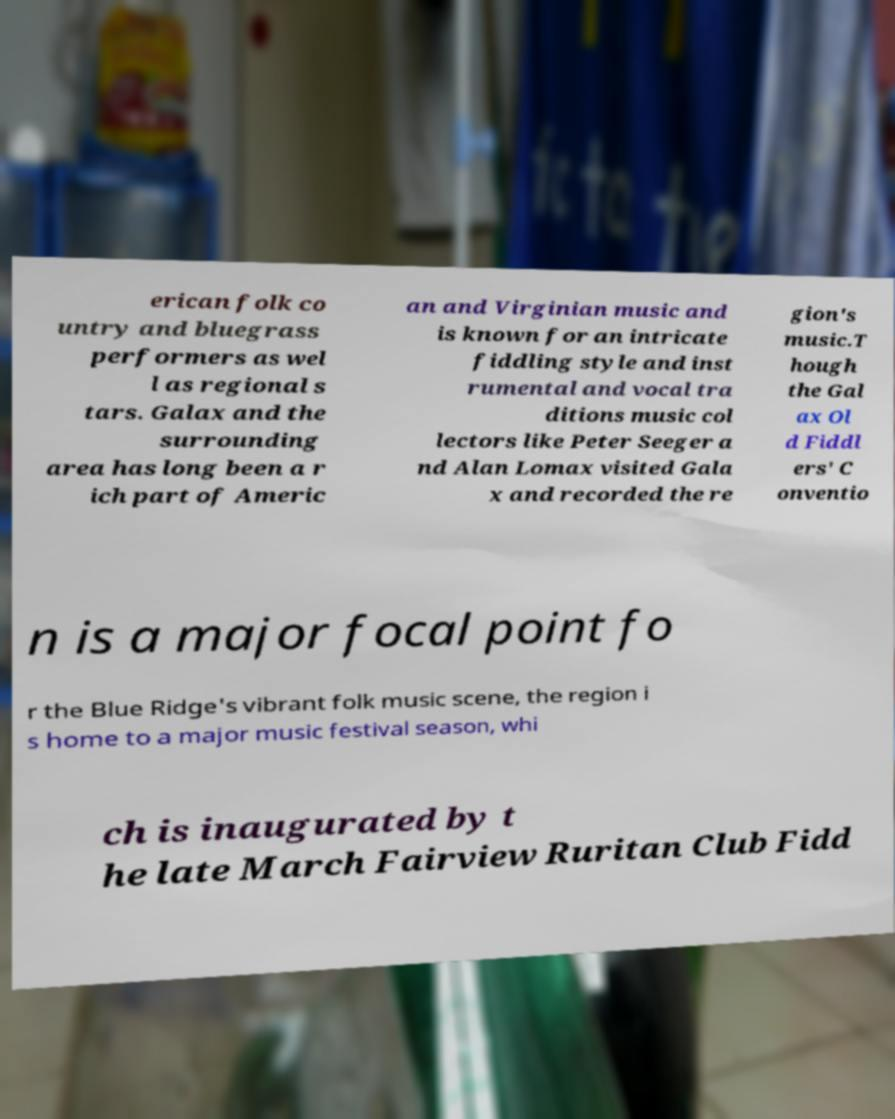Could you extract and type out the text from this image? erican folk co untry and bluegrass performers as wel l as regional s tars. Galax and the surrounding area has long been a r ich part of Americ an and Virginian music and is known for an intricate fiddling style and inst rumental and vocal tra ditions music col lectors like Peter Seeger a nd Alan Lomax visited Gala x and recorded the re gion's music.T hough the Gal ax Ol d Fiddl ers' C onventio n is a major focal point fo r the Blue Ridge's vibrant folk music scene, the region i s home to a major music festival season, whi ch is inaugurated by t he late March Fairview Ruritan Club Fidd 